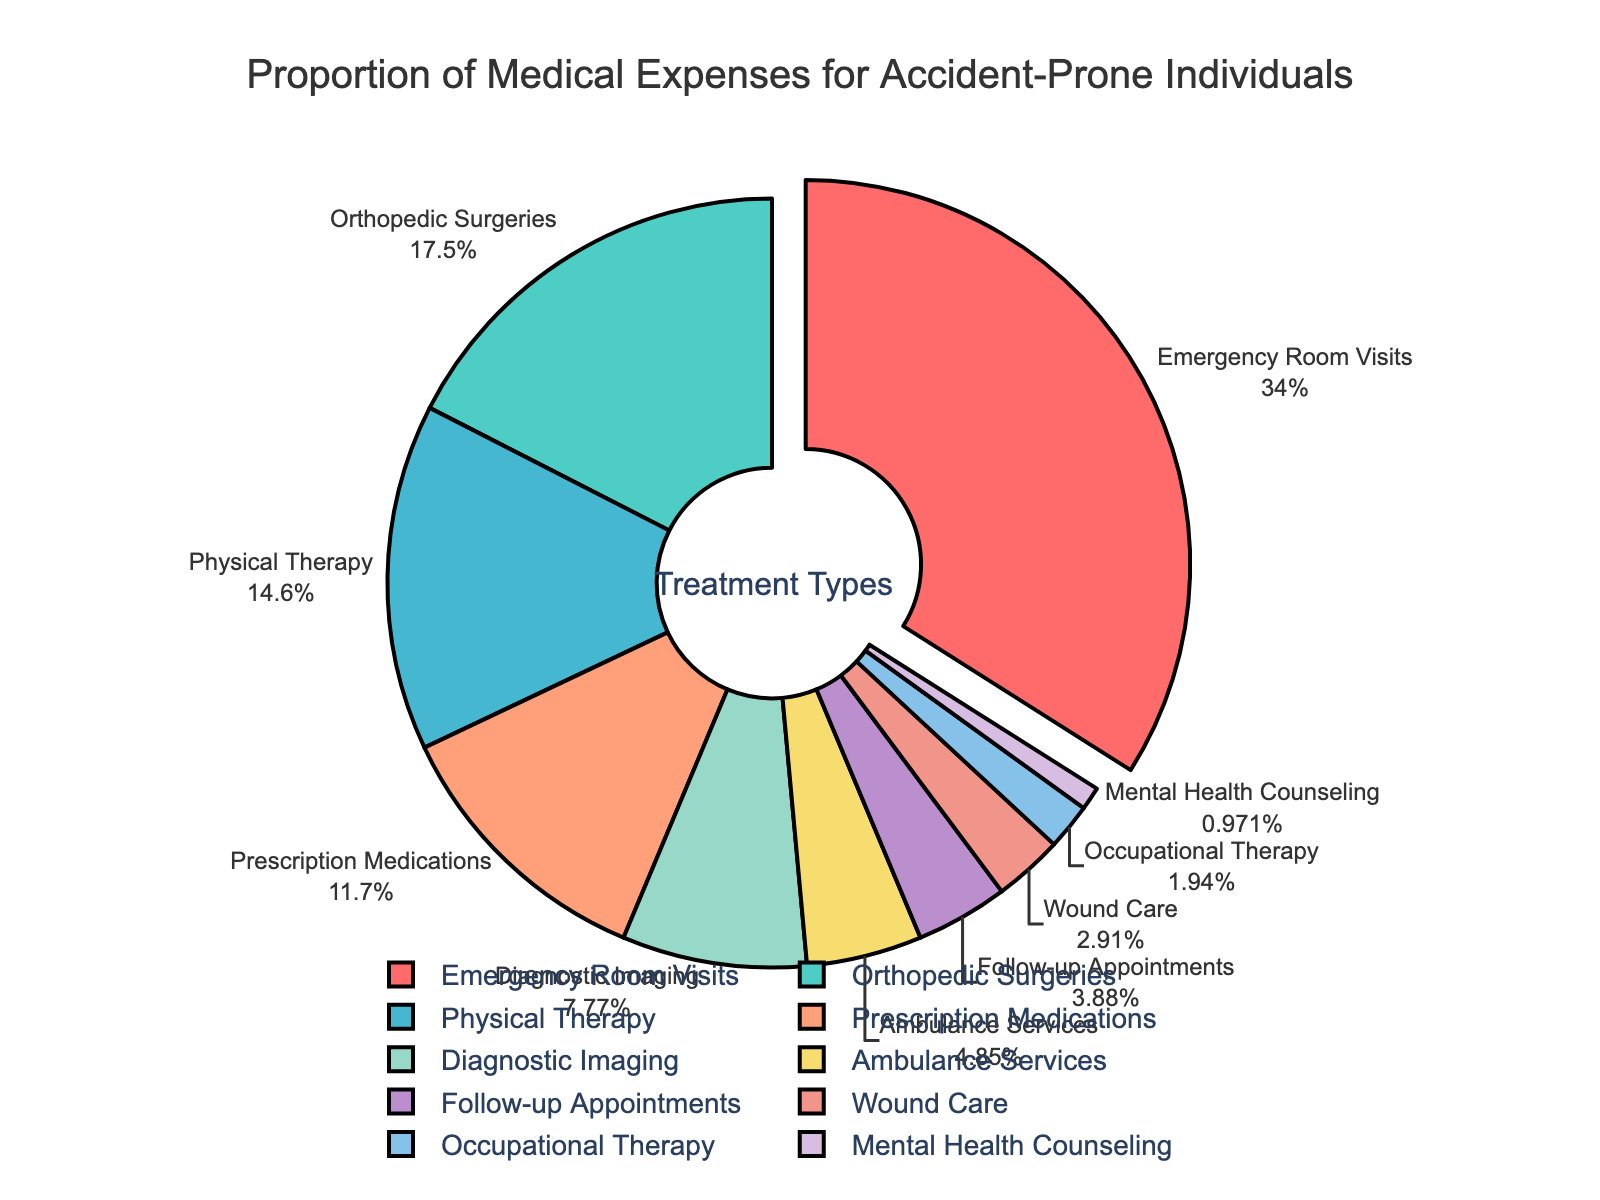What's the largest proportion of medical expenses by treatment type? The largest proportion can be seen by identifying the segment of the pie chart that represents the highest percentage. The segment for Emergency Room Visits is pulled out from the pie, indicating it has the highest percentage, which is 35%.
Answer: Emergency Room Visits How do the expenses for Prescription Medications compare to those for Physical Therapy? By looking at the pie chart, the segment for Prescription Medications represents 12%, and the segment for Physical Therapy represents 15%. Since 15% is greater than 12%, the expenses for Physical Therapy are higher than those for Prescription Medications.
Answer: Physical Therapy expenses are higher What is the combined percentage of expenses for Diagnostic Imaging and Ambulance Services? According to the pie chart, Diagnostic Imaging is 8% and Ambulance Services is 5%. Adding these together, you get 8% + 5% = 13%.
Answer: 13% Which treatment type has the smallest proportion of medical expenses? The pie chart shows various percentages. The smallest segment is for Mental Health Counseling, which represents 1%.
Answer: Mental Health Counseling How much higher are the Emergency Room Visits expenses compared to Orthopedic Surgeries? Emergency Room Visits represent 35%, and Orthopedic Surgeries represent 18%. Subtracting the Orthopedic Surgeries percentage from the Emergency Room Visits percentage, you get 35% - 18% = 17%.
Answer: 17% What is the total percentage for Physical Therapy, Follow-up Appointments, and Wound Care combined? The pie chart shows Physical Therapy as 15%, Follow-up Appointments as 4%, and Wound Care as 3%. Adding these together, you get 15% + 4% + 3% = 22%.
Answer: 22% Which segment of the pie chart is represented by a blue color, and what is its percentage? Visually identifying the color segments in the pie chart, we find that Diagnostic Imaging is represented by blue and has a percentage of 8%.
Answer: Diagnostic Imaging (8%) Is the combined percentage of Ambulance Services and Occupational Therapy greater than that of Orthopedic Surgeries? The pie chart shows Ambulance Services as 5% and Occupational Therapy as 2%, totaling 5% + 2% = 7%. Orthopedic Surgeries are 18%. Since 7% is less than 18%, the combined percentage of Ambulance Services and Occupational Therapy is not greater.
Answer: No What proportion of the medical expenses is designated for orthopedic-related treatments (Orthopedic Surgeries and Physical Therapy)? Orthopedic Surgeries represent 18%, and Physical Therapy represents 15%. Adding these together, you get 18% + 15% = 33%.
Answer: 33% 